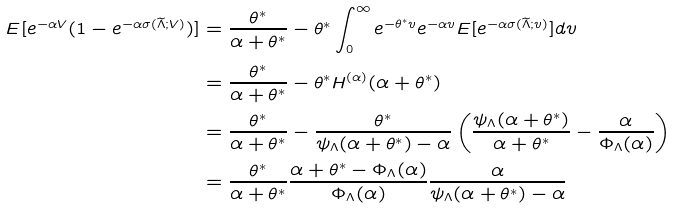Convert formula to latex. <formula><loc_0><loc_0><loc_500><loc_500>E [ e ^ { - \alpha V } ( 1 - e ^ { - \alpha \sigma ( \widetilde { \Lambda } ; V ) } ) ] & = \frac { \theta ^ { * } } { \alpha + \theta ^ { * } } - \theta ^ { * } \int _ { 0 } ^ { \infty } e ^ { - \theta ^ { * } v } e ^ { - \alpha v } E [ e ^ { - \alpha \sigma ( \widetilde { \Lambda } ; v ) } ] d v \\ & = \frac { \theta ^ { * } } { \alpha + \theta ^ { * } } - \theta ^ { * } H ^ { ( \alpha ) } ( \alpha + \theta ^ { * } ) \\ & = \frac { \theta ^ { * } } { \alpha + \theta ^ { * } } - \frac { \theta ^ { * } } { \psi _ { \Lambda } ( \alpha + \theta ^ { * } ) - \alpha } \left ( \frac { \psi _ { \Lambda } ( \alpha + \theta ^ { * } ) } { \alpha + \theta ^ { * } } - \frac { \alpha } { \Phi _ { \Lambda } ( \alpha ) } \right ) \\ & = \frac { \theta ^ { * } } { \alpha + \theta ^ { * } } \frac { \alpha + \theta ^ { * } - \Phi _ { \Lambda } ( \alpha ) } { \Phi _ { \Lambda } ( \alpha ) } \frac { \alpha } { \psi _ { \Lambda } ( \alpha + \theta ^ { * } ) - \alpha }</formula> 